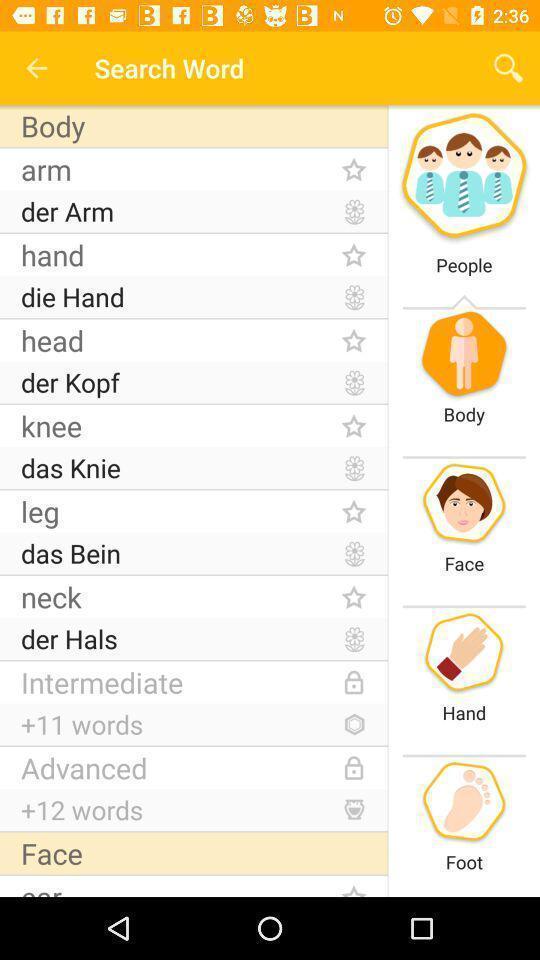Tell me about the visual elements in this screen capture. Search page of words in learning app. 